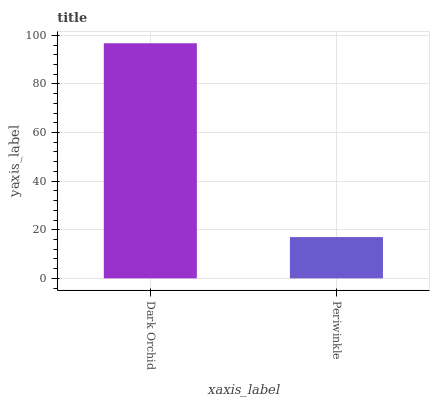Is Periwinkle the maximum?
Answer yes or no. No. Is Dark Orchid greater than Periwinkle?
Answer yes or no. Yes. Is Periwinkle less than Dark Orchid?
Answer yes or no. Yes. Is Periwinkle greater than Dark Orchid?
Answer yes or no. No. Is Dark Orchid less than Periwinkle?
Answer yes or no. No. Is Dark Orchid the high median?
Answer yes or no. Yes. Is Periwinkle the low median?
Answer yes or no. Yes. Is Periwinkle the high median?
Answer yes or no. No. Is Dark Orchid the low median?
Answer yes or no. No. 